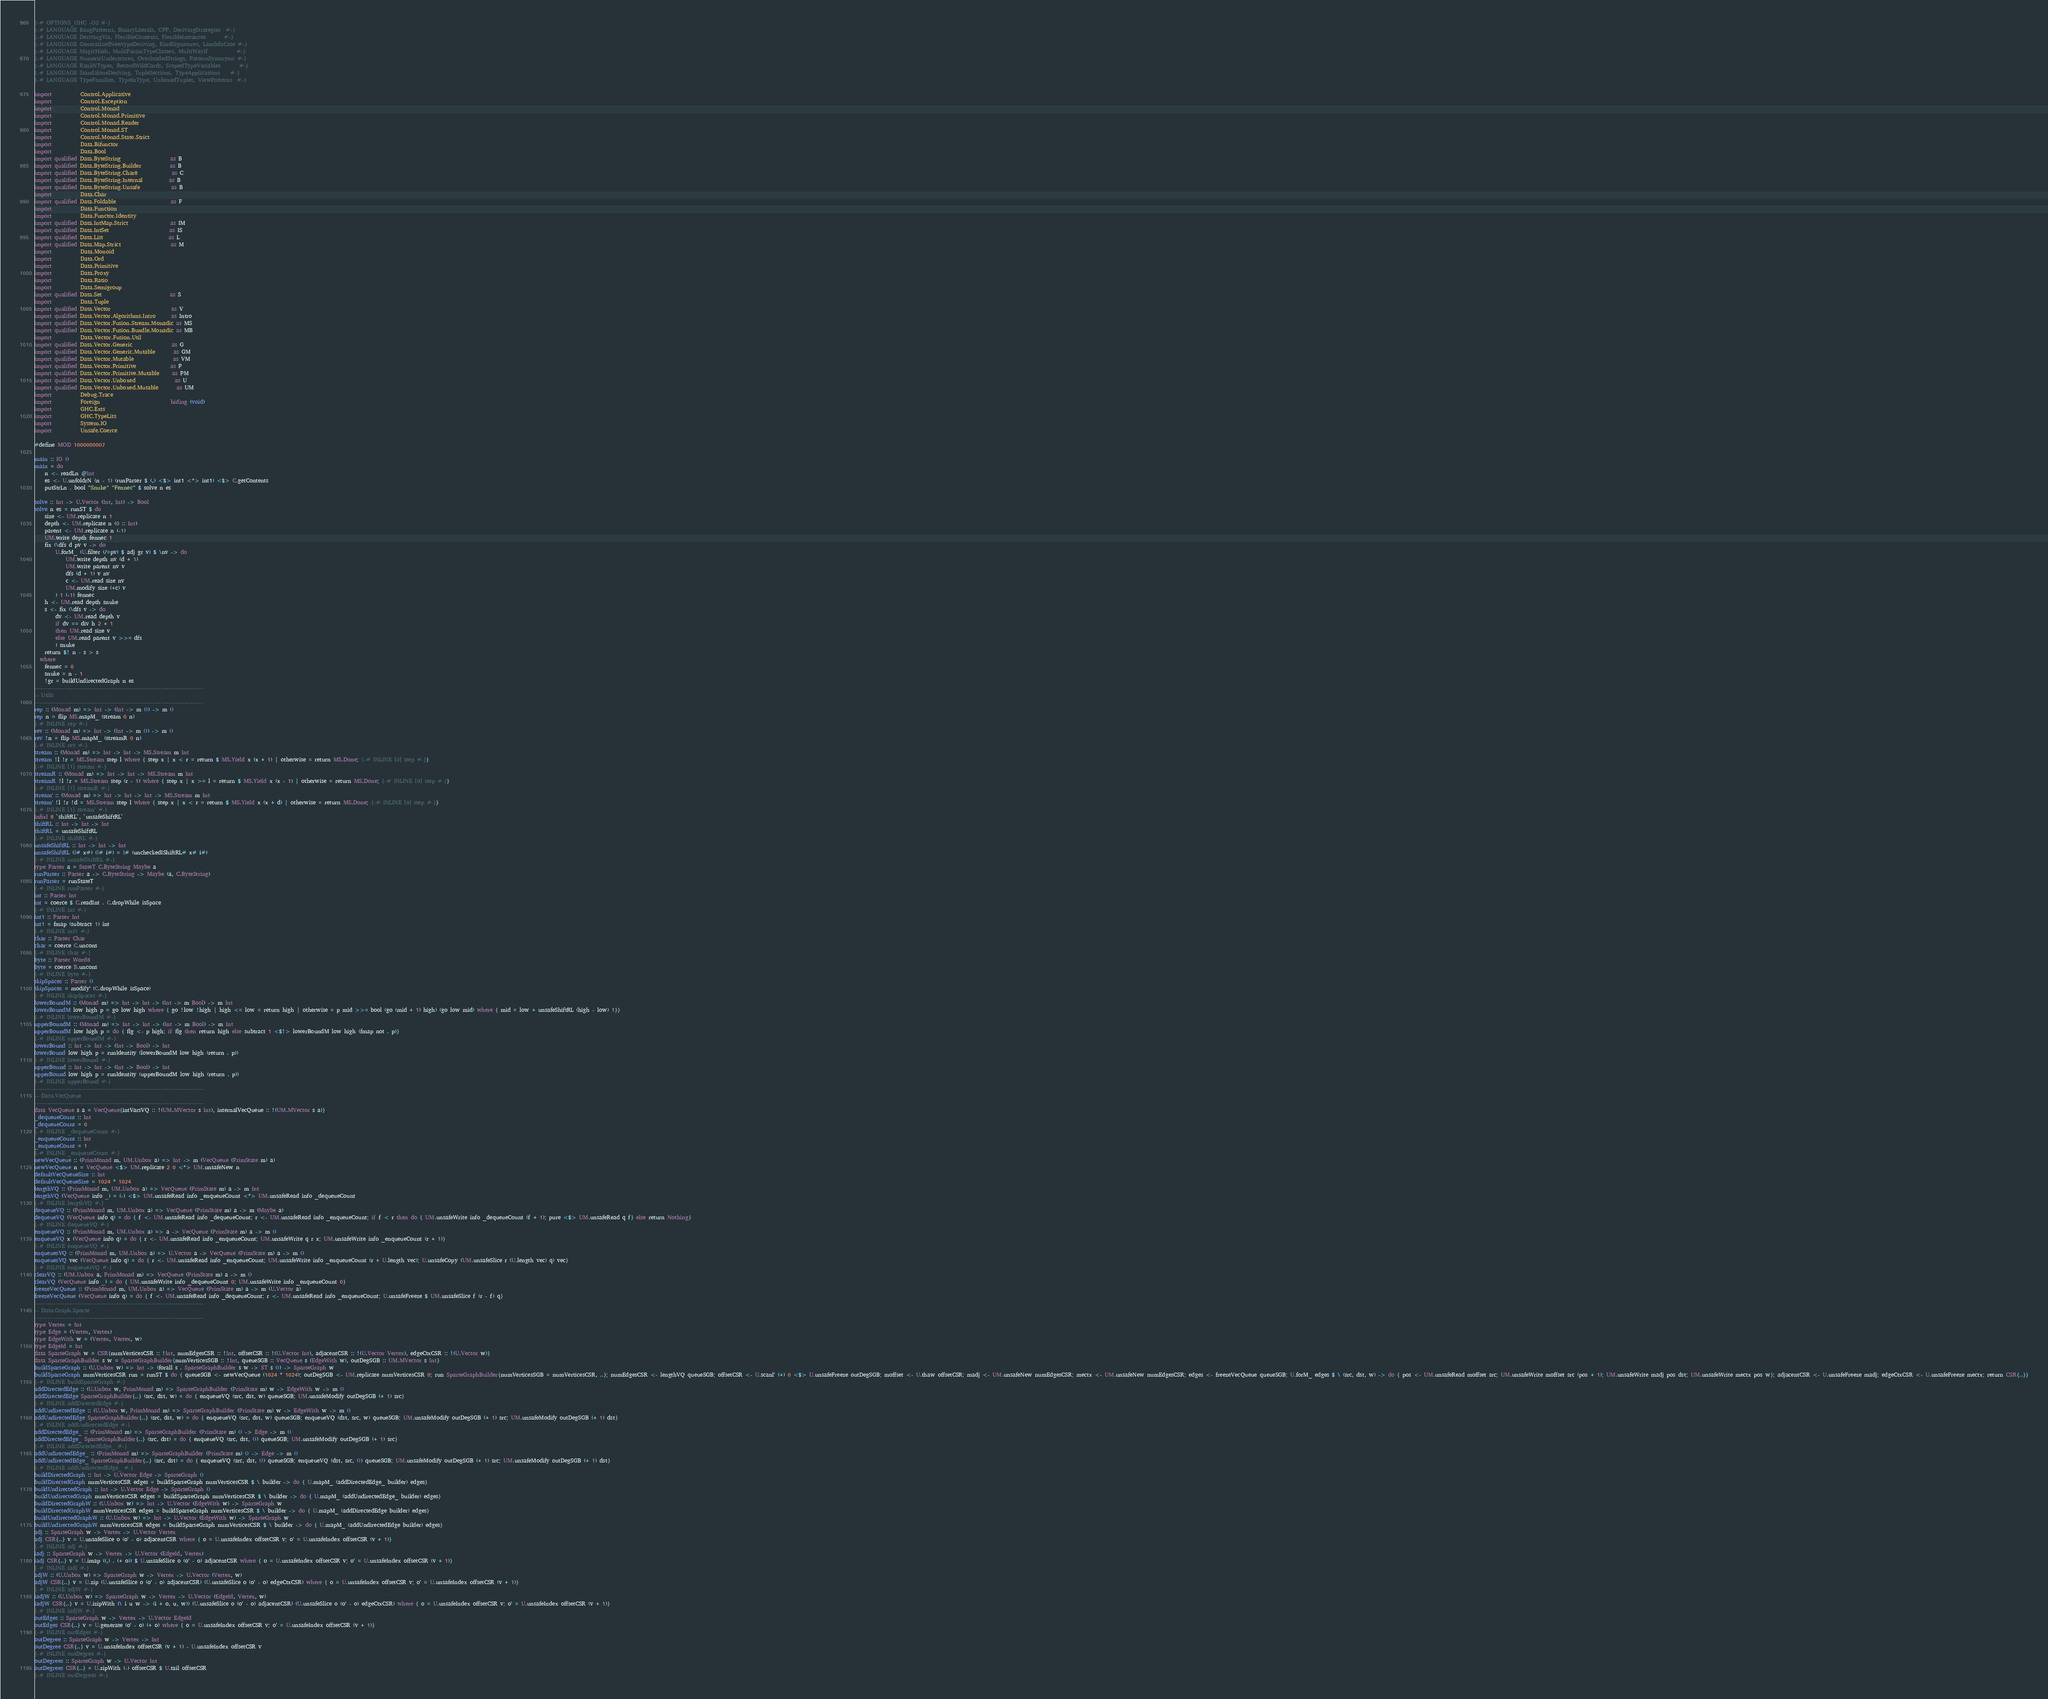<code> <loc_0><loc_0><loc_500><loc_500><_Haskell_>{-# OPTIONS_GHC -O2 #-}
{-# LANGUAGE BangPatterns, BinaryLiterals, CPP, DerivingStrategies  #-}
{-# LANGUAGE DerivingVia, FlexibleContexts, FlexibleInstances       #-}
{-# LANGUAGE GeneralizedNewtypeDeriving, KindSignatures, LambdaCase #-}
{-# LANGUAGE MagicHash, MultiParamTypeClasses, MultiWayIf           #-}
{-# LANGUAGE NumericUnderscores, OverloadedStrings, PatternSynonyms #-}
{-# LANGUAGE RankNTypes, RecordWildCards, ScopedTypeVariables       #-}
{-# LANGUAGE StandaloneDeriving, TupleSections, TypeApplications    #-}
{-# LANGUAGE TypeFamilies, TypeInType, UnboxedTuples, ViewPatterns  #-}

import           Control.Applicative
import           Control.Exception
import           Control.Monad
import           Control.Monad.Primitive
import           Control.Monad.Reader
import           Control.Monad.ST
import           Control.Monad.State.Strict
import           Data.Bifunctor
import           Data.Bool
import qualified Data.ByteString                   as B
import qualified Data.ByteString.Builder           as B
import qualified Data.ByteString.Char8             as C
import qualified Data.ByteString.Internal          as B
import qualified Data.ByteString.Unsafe            as B
import           Data.Char
import qualified Data.Foldable                     as F
import           Data.Function
import           Data.Functor.Identity
import qualified Data.IntMap.Strict                as IM
import qualified Data.IntSet                       as IS
import qualified Data.List                         as L
import qualified Data.Map.Strict                   as M
import           Data.Monoid
import           Data.Ord
import           Data.Primitive
import           Data.Proxy
import           Data.Ratio
import           Data.Semigroup
import qualified Data.Set                          as S
import           Data.Tuple
import qualified Data.Vector                       as V
import qualified Data.Vector.Algorithms.Intro      as Intro
import qualified Data.Vector.Fusion.Stream.Monadic as MS
import qualified Data.Vector.Fusion.Bundle.Monadic as MB
import           Data.Vector.Fusion.Util
import qualified Data.Vector.Generic               as G
import qualified Data.Vector.Generic.Mutable       as GM
import qualified Data.Vector.Mutable               as VM
import qualified Data.Vector.Primitive             as P
import qualified Data.Vector.Primitive.Mutable     as PM
import qualified Data.Vector.Unboxed               as U
import qualified Data.Vector.Unboxed.Mutable       as UM
import           Debug.Trace
import           Foreign                           hiding (void)
import           GHC.Exts
import           GHC.TypeLits
import           System.IO
import           Unsafe.Coerce

#define MOD 1000000007

main :: IO ()
main = do
    n <- readLn @Int
    es <- U.unfoldrN (n - 1) (runParser $ (,) <$> int1 <*> int1) <$> C.getContents
    putStrLn . bool "Snuke" "Fennec" $ solve n es

solve :: Int -> U.Vector (Int, Int) -> Bool
solve n es = runST $ do
    size <- UM.replicate n 1
    depth <- UM.replicate n (0 :: Int)
    parent <- UM.replicate n (-1)
    UM.write depth fennec 1
    fix (\dfs d pv v -> do
        U.forM_ (U.filter (/=pv) $ adj gr v) $ \nv -> do
            UM.write depth nv (d + 1)
            UM.write parent nv v
            dfs (d + 1) v nv
            c <- UM.read size nv
            UM.modify size (+c) v
        ) 1 (-1) fennec
    h <- UM.read depth snuke
    s <- fix (\dfs v -> do
        dv <- UM.read depth v
        if dv == div h 2 + 1
        then UM.read size v
        else UM.read parent v >>= dfs
        ) snuke
    return $! n - s > s
  where
    fennec = 0
    snuke = n - 1
    !gr = buildUndirectedGraph n es
-------------------------------------------------------------------------------
-- Utils
-------------------------------------------------------------------------------
rep :: (Monad m) => Int -> (Int -> m ()) -> m ()
rep n = flip MS.mapM_ (stream 0 n)
{-# INLINE rep #-}
rev :: (Monad m) => Int -> (Int -> m ()) -> m ()
rev !n = flip MS.mapM_ (streamR 0 n)
{-# INLINE rev #-}
stream :: (Monad m) => Int -> Int -> MS.Stream m Int
stream !l !r = MS.Stream step l where { step x | x < r = return $ MS.Yield x (x + 1) | otherwise = return MS.Done; {-# INLINE [0] step #-}}
{-# INLINE [1] stream #-}
streamR :: (Monad m) => Int -> Int -> MS.Stream m Int
streamR !l !r = MS.Stream step (r - 1) where { step x | x >= l = return $ MS.Yield x (x - 1) | otherwise = return MS.Done; {-# INLINE [0] step #-}}
{-# INLINE [1] streamR #-}
stream' :: (Monad m) => Int -> Int -> Int -> MS.Stream m Int
stream' !l !r !d = MS.Stream step l where { step x | x < r = return $ MS.Yield x (x + d) | otherwise = return MS.Done; {-# INLINE [0] step #-}}
{-# INLINE [1] stream' #-}
infixl 8 `shiftRL`, `unsafeShiftRL`
shiftRL :: Int -> Int -> Int
shiftRL = unsafeShiftRL
{-# INLINE shiftRL #-}
unsafeShiftRL :: Int -> Int -> Int
unsafeShiftRL (I# x#) (I# i#) = I# (uncheckedIShiftRL# x# i#)
{-# INLINE unsafeShiftRL #-}
type Parser a = StateT C.ByteString Maybe a
runParser :: Parser a -> C.ByteString -> Maybe (a, C.ByteString)
runParser = runStateT
{-# INLINE runParser #-}
int :: Parser Int
int = coerce $ C.readInt . C.dropWhile isSpace
{-# INLINE int #-}
int1 :: Parser Int
int1 = fmap (subtract 1) int
{-# INLINE int1 #-}
char :: Parser Char
char = coerce C.uncons
{-# INLINE char #-}
byte :: Parser Word8
byte = coerce B.uncons
{-# INLINE byte #-}
skipSpaces :: Parser ()
skipSpaces = modify' (C.dropWhile isSpace)
{-# INLINE skipSpaces #-}
lowerBoundM :: (Monad m) => Int -> Int -> (Int -> m Bool) -> m Int
lowerBoundM low high p = go low high where { go !low !high | high <= low = return high | otherwise = p mid >>= bool (go (mid + 1) high) (go low mid) where { mid = low + unsafeShiftRL (high - low) 1}}
{-# INLINE lowerBoundM #-}
upperBoundM :: (Monad m) => Int -> Int -> (Int -> m Bool) -> m Int
upperBoundM low high p = do { flg <- p high; if flg then return high else subtract 1 <$!> lowerBoundM low high (fmap not . p)}
{-# INLINE upperBoundM #-}
lowerBound :: Int -> Int -> (Int -> Bool) -> Int
lowerBound low high p = runIdentity (lowerBoundM low high (return . p))
{-# INLINE lowerBound #-}
upperBound :: Int -> Int -> (Int -> Bool) -> Int
upperBound low high p = runIdentity (upperBoundM low high (return . p))
{-# INLINE upperBound #-}
-------------------------------------------------------------------------------
-- Data.VecQueue
-------------------------------------------------------------------------------
data VecQueue s a = VecQueue{intVarsVQ :: !(UM.MVector s Int), internalVecQueue :: !(UM.MVector s a)}
_dequeueCount :: Int
_dequeueCount = 0
{-# INLINE _dequeueCount #-}
_enqueueCount :: Int
_enqueueCount = 1
{-# INLINE _enqueueCount #-}
newVecQueue :: (PrimMonad m, UM.Unbox a) => Int -> m (VecQueue (PrimState m) a)
newVecQueue n = VecQueue <$> UM.replicate 2 0 <*> UM.unsafeNew n
defaultVecQueueSize :: Int
defaultVecQueueSize = 1024 * 1024
lengthVQ :: (PrimMonad m, UM.Unbox a) => VecQueue (PrimState m) a -> m Int
lengthVQ (VecQueue info _) = (-) <$> UM.unsafeRead info _enqueueCount <*> UM.unsafeRead info _dequeueCount
{-# INLINE lengthVQ #-}
dequeueVQ :: (PrimMonad m, UM.Unbox a) => VecQueue (PrimState m) a -> m (Maybe a)
dequeueVQ (VecQueue info q) = do { f <- UM.unsafeRead info _dequeueCount; r <- UM.unsafeRead info _enqueueCount; if f < r then do { UM.unsafeWrite info _dequeueCount (f + 1); pure <$> UM.unsafeRead q f} else return Nothing}
{-# INLINE dequeueVQ #-}
enqueueVQ :: (PrimMonad m, UM.Unbox a) => a -> VecQueue (PrimState m) a -> m ()
enqueueVQ x (VecQueue info q) = do { r <- UM.unsafeRead info _enqueueCount; UM.unsafeWrite q r x; UM.unsafeWrite info _enqueueCount (r + 1)}
{-# INLINE enqueueVQ #-}
enqueuesVQ :: (PrimMonad m, UM.Unbox a) => U.Vector a -> VecQueue (PrimState m) a -> m ()
enqueuesVQ vec (VecQueue info q) = do { r <- UM.unsafeRead info _enqueueCount; UM.unsafeWrite info _enqueueCount (r + U.length vec); U.unsafeCopy (UM.unsafeSlice r (U.length vec) q) vec}
{-# INLINE enqueuesVQ #-}
clearVQ :: (UM.Unbox a, PrimMonad m) => VecQueue (PrimState m) a -> m ()
clearVQ (VecQueue info _) = do { UM.unsafeWrite info _dequeueCount 0; UM.unsafeWrite info _enqueueCount 0}
freezeVecQueue :: (PrimMonad m, UM.Unbox a) => VecQueue (PrimState m) a -> m (U.Vector a)
freezeVecQueue (VecQueue info q) = do { f <- UM.unsafeRead info _dequeueCount; r <- UM.unsafeRead info _enqueueCount; U.unsafeFreeze $ UM.unsafeSlice f (r - f) q}
-------------------------------------------------------------------------------
-- Data.Graph.Sparse
-------------------------------------------------------------------------------
type Vertex = Int
type Edge = (Vertex, Vertex)
type EdgeWith w = (Vertex, Vertex, w)
type EdgeId = Int
data SparseGraph w = CSR{numVerticesCSR :: !Int, numEdgesCSR :: !Int, offsetCSR :: !(U.Vector Int), adjacentCSR :: !(U.Vector Vertex), edgeCtxCSR :: !(U.Vector w)}
data SparseGraphBuilder s w = SparseGraphBuilder{numVerticesSGB :: !Int, queueSGB :: VecQueue s (EdgeWith w), outDegSGB :: UM.MVector s Int}
buildSparseGraph :: (U.Unbox w) => Int -> (forall s . SparseGraphBuilder s w -> ST s ()) -> SparseGraph w
buildSparseGraph numVerticesCSR run = runST $ do { queueSGB <- newVecQueue (1024 * 1024); outDegSGB <- UM.replicate numVerticesCSR 0; run SparseGraphBuilder{numVerticesSGB = numVerticesCSR, ..}; numEdgesCSR <- lengthVQ queueSGB; offsetCSR <- U.scanl' (+) 0 <$> U.unsafeFreeze outDegSGB; moffset <- U.thaw offsetCSR; madj <- UM.unsafeNew numEdgesCSR; mectx <- UM.unsafeNew numEdgesCSR; edges <- freezeVecQueue queueSGB; U.forM_ edges $ \ (src, dst, w) -> do { pos <- UM.unsafeRead moffset src; UM.unsafeWrite moffset src (pos + 1); UM.unsafeWrite madj pos dst; UM.unsafeWrite mectx pos w}; adjacentCSR <- U.unsafeFreeze madj; edgeCtxCSR <- U.unsafeFreeze mectx; return CSR{..}}
{-# INLINE buildSparseGraph #-}
addDirectedEdge :: (U.Unbox w, PrimMonad m) => SparseGraphBuilder (PrimState m) w -> EdgeWith w -> m ()
addDirectedEdge SparseGraphBuilder{..} (src, dst, w) = do { enqueueVQ (src, dst, w) queueSGB; UM.unsafeModify outDegSGB (+ 1) src}
{-# INLINE addDirectedEdge #-}
addUndirectedEdge :: (U.Unbox w, PrimMonad m) => SparseGraphBuilder (PrimState m) w -> EdgeWith w -> m ()
addUndirectedEdge SparseGraphBuilder{..} (src, dst, w) = do { enqueueVQ (src, dst, w) queueSGB; enqueueVQ (dst, src, w) queueSGB; UM.unsafeModify outDegSGB (+ 1) src; UM.unsafeModify outDegSGB (+ 1) dst}
{-# INLINE addUndirectedEdge #-}
addDirectedEdge_ :: (PrimMonad m) => SparseGraphBuilder (PrimState m) () -> Edge -> m ()
addDirectedEdge_ SparseGraphBuilder{..} (src, dst) = do { enqueueVQ (src, dst, ()) queueSGB; UM.unsafeModify outDegSGB (+ 1) src}
{-# INLINE addDirectedEdge_ #-}
addUndirectedEdge_ :: (PrimMonad m) => SparseGraphBuilder (PrimState m) () -> Edge -> m ()
addUndirectedEdge_ SparseGraphBuilder{..} (src, dst) = do { enqueueVQ (src, dst, ()) queueSGB; enqueueVQ (dst, src, ()) queueSGB; UM.unsafeModify outDegSGB (+ 1) src; UM.unsafeModify outDegSGB (+ 1) dst}
{-# INLINE addUndirectedEdge_ #-}
buildDirectedGraph :: Int -> U.Vector Edge -> SparseGraph ()
buildDirectedGraph numVerticesCSR edges = buildSparseGraph numVerticesCSR $ \ builder -> do { U.mapM_ (addDirectedEdge_ builder) edges}
buildUndirectedGraph :: Int -> U.Vector Edge -> SparseGraph ()
buildUndirectedGraph numVerticesCSR edges = buildSparseGraph numVerticesCSR $ \ builder -> do { U.mapM_ (addUndirectedEdge_ builder) edges}
buildDirectedGraphW :: (U.Unbox w) => Int -> U.Vector (EdgeWith w) -> SparseGraph w
buildDirectedGraphW numVerticesCSR edges = buildSparseGraph numVerticesCSR $ \ builder -> do { U.mapM_ (addDirectedEdge builder) edges}
buildUndirectedGraphW :: (U.Unbox w) => Int -> U.Vector (EdgeWith w) -> SparseGraph w
buildUndirectedGraphW numVerticesCSR edges = buildSparseGraph numVerticesCSR $ \ builder -> do { U.mapM_ (addUndirectedEdge builder) edges}
adj :: SparseGraph w -> Vertex -> U.Vector Vertex
adj CSR{..} v = U.unsafeSlice o (o' - o) adjacentCSR where { o = U.unsafeIndex offsetCSR v; o' = U.unsafeIndex offsetCSR (v + 1)}
{-# INLINE adj #-}
iadj :: SparseGraph w -> Vertex -> U.Vector (EdgeId, Vertex)
iadj CSR{..} v = U.imap ((,) . (+ o)) $ U.unsafeSlice o (o' - o) adjacentCSR where { o = U.unsafeIndex offsetCSR v; o' = U.unsafeIndex offsetCSR (v + 1)}
{-# INLINE iadj #-}
adjW :: (U.Unbox w) => SparseGraph w -> Vertex -> U.Vector (Vertex, w)
adjW CSR{..} v = U.zip (U.unsafeSlice o (o' - o) adjacentCSR) (U.unsafeSlice o (o' - o) edgeCtxCSR) where { o = U.unsafeIndex offsetCSR v; o' = U.unsafeIndex offsetCSR (v + 1)}
{-# INLINE adjW #-}
iadjW :: (U.Unbox w) => SparseGraph w -> Vertex -> U.Vector (EdgeId, Vertex, w)
iadjW CSR{..} v = U.izipWith (\ i u w -> (i + o, u, w)) (U.unsafeSlice o (o' - o) adjacentCSR) (U.unsafeSlice o (o' - o) edgeCtxCSR) where { o = U.unsafeIndex offsetCSR v; o' = U.unsafeIndex offsetCSR (v + 1)}
{-# INLINE iadjW #-}
outEdges :: SparseGraph w -> Vertex -> U.Vector EdgeId
outEdges CSR{..} v = U.generate (o' - o) (+ o) where { o = U.unsafeIndex offsetCSR v; o' = U.unsafeIndex offsetCSR (v + 1)}
{-# INLINE outEdges #-}
outDegree :: SparseGraph w -> Vertex -> Int
outDegree CSR{..} v = U.unsafeIndex offsetCSR (v + 1) - U.unsafeIndex offsetCSR v
{-# INLINE outDegree #-}
outDegrees :: SparseGraph w -> U.Vector Int
outDegrees CSR{..} = U.zipWith (-) offsetCSR $ U.tail offsetCSR
{-# INLINE outDegrees #-}
</code> 